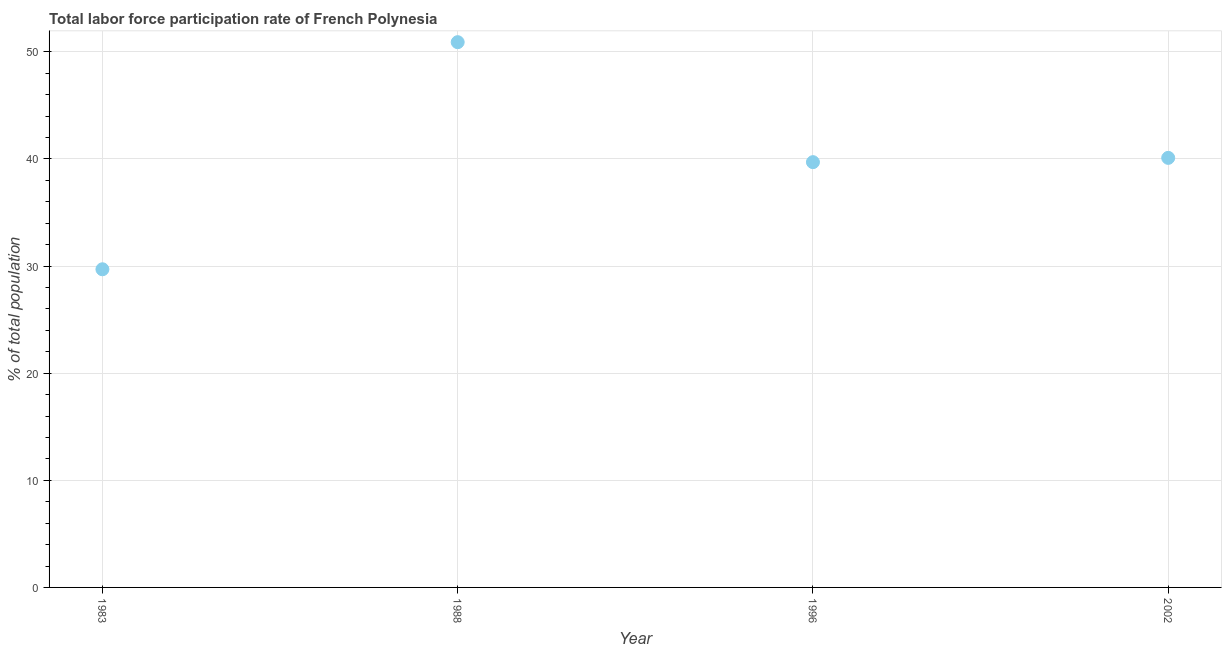What is the total labor force participation rate in 2002?
Keep it short and to the point. 40.1. Across all years, what is the maximum total labor force participation rate?
Offer a terse response. 50.9. Across all years, what is the minimum total labor force participation rate?
Your answer should be very brief. 29.7. What is the sum of the total labor force participation rate?
Your response must be concise. 160.4. What is the difference between the total labor force participation rate in 1983 and 1996?
Your answer should be very brief. -10. What is the average total labor force participation rate per year?
Provide a succinct answer. 40.1. What is the median total labor force participation rate?
Provide a succinct answer. 39.9. What is the ratio of the total labor force participation rate in 1988 to that in 1996?
Your answer should be compact. 1.28. Is the total labor force participation rate in 1983 less than that in 1988?
Offer a very short reply. Yes. Is the difference between the total labor force participation rate in 1988 and 1996 greater than the difference between any two years?
Your response must be concise. No. What is the difference between the highest and the second highest total labor force participation rate?
Your response must be concise. 10.8. Is the sum of the total labor force participation rate in 1983 and 1996 greater than the maximum total labor force participation rate across all years?
Ensure brevity in your answer.  Yes. What is the difference between the highest and the lowest total labor force participation rate?
Provide a succinct answer. 21.2. How many dotlines are there?
Keep it short and to the point. 1. How many years are there in the graph?
Your answer should be very brief. 4. Are the values on the major ticks of Y-axis written in scientific E-notation?
Offer a very short reply. No. Does the graph contain any zero values?
Offer a very short reply. No. What is the title of the graph?
Provide a short and direct response. Total labor force participation rate of French Polynesia. What is the label or title of the X-axis?
Ensure brevity in your answer.  Year. What is the label or title of the Y-axis?
Offer a terse response. % of total population. What is the % of total population in 1983?
Make the answer very short. 29.7. What is the % of total population in 1988?
Make the answer very short. 50.9. What is the % of total population in 1996?
Offer a terse response. 39.7. What is the % of total population in 2002?
Provide a succinct answer. 40.1. What is the difference between the % of total population in 1983 and 1988?
Provide a succinct answer. -21.2. What is the difference between the % of total population in 1988 and 1996?
Give a very brief answer. 11.2. What is the ratio of the % of total population in 1983 to that in 1988?
Provide a short and direct response. 0.58. What is the ratio of the % of total population in 1983 to that in 1996?
Your answer should be very brief. 0.75. What is the ratio of the % of total population in 1983 to that in 2002?
Make the answer very short. 0.74. What is the ratio of the % of total population in 1988 to that in 1996?
Make the answer very short. 1.28. What is the ratio of the % of total population in 1988 to that in 2002?
Your response must be concise. 1.27. 